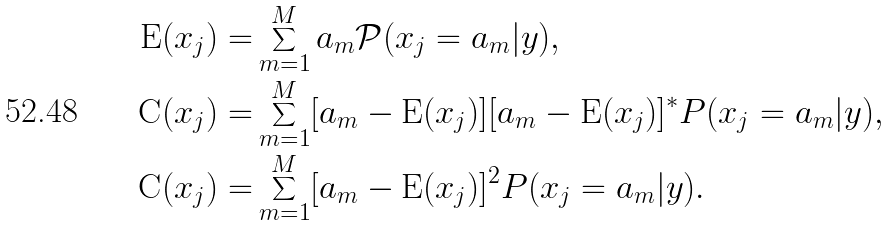Convert formula to latex. <formula><loc_0><loc_0><loc_500><loc_500>\text  E (x_{j} ) = & \sum _ { m = 1 } ^ { M } a _ { m } \mathcal { P } ( { x _ { j } = a _ { m } } | { y } ) , \\ { \text  C}(x_{j}) = &\sum_{m=1}^{M}[a_{m} - \text  E(x_{j})][a_{m} - \text  E(x_{j})]^{*}\mathcal{ }P({x_{j} = a _ { m } } | { y } ) , \\ { \underline { } { \text  C}}(x_{j})=&\sum_{m=1}^{M}[a_{m}-\text  E(x_{j})]^{2} \mathcal{ }P({x_{j} = a_{m}}|{y}).</formula> 